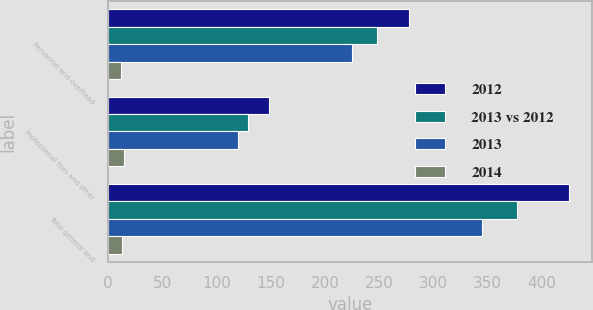Convert chart. <chart><loc_0><loc_0><loc_500><loc_500><stacked_bar_chart><ecel><fcel>Personnel and overhead<fcel>Professional fees and other<fcel>Total general and<nl><fcel>2012<fcel>277<fcel>148<fcel>425<nl><fcel>2013 vs 2012<fcel>248<fcel>129<fcel>377<nl><fcel>2013<fcel>225<fcel>120<fcel>345<nl><fcel>2014<fcel>12<fcel>15<fcel>13<nl></chart> 